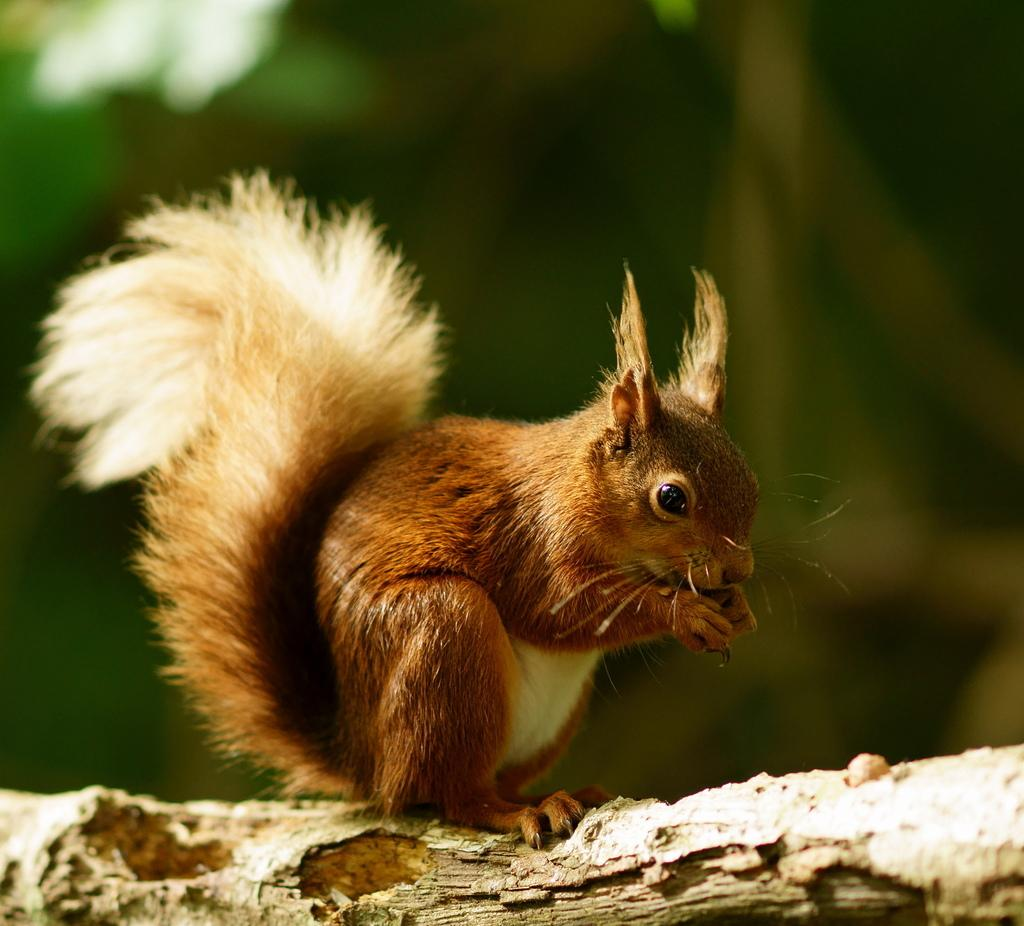What animal is present in the image? There is a squirrel in the image. What colors can be seen on the squirrel? The squirrel is brown, cream, and black in color. Where is the squirrel located in the image? The squirrel is on a tree branch. Can you describe the background of the image? The background of the image is blurry, and the background color is green. What type of cloth is being used to cover the cannon in the image? There is no cloth or cannon present in the image; it features a squirrel on a tree branch. What tool is the squirrel using to tighten the wrench in the image? There is no wrench or tool usage depicted in the image; the squirrel is simply sitting on a tree branch. 